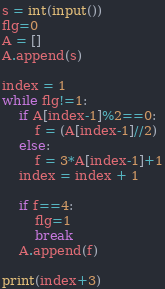Convert code to text. <code><loc_0><loc_0><loc_500><loc_500><_Python_>s = int(input())
flg=0
A = []
A.append(s)

index = 1
while flg!=1:
    if A[index-1]%2==0:
        f = (A[index-1]//2)
    else:
        f = 3*A[index-1]+1
    index = index + 1
    
    if f==4:
        flg=1
        break
    A.append(f)

print(index+3)</code> 